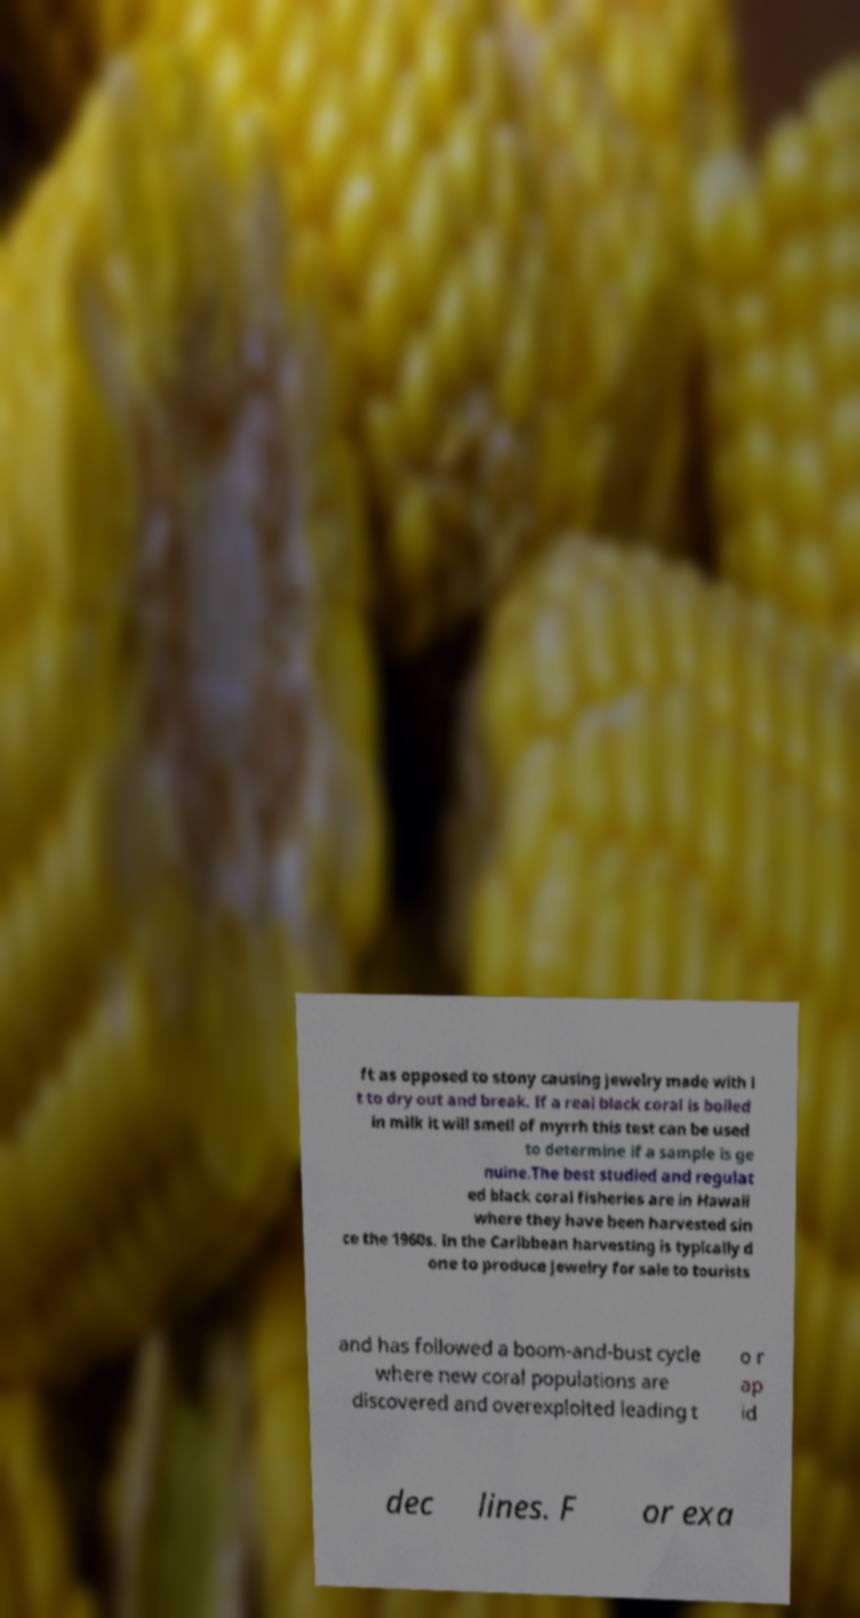I need the written content from this picture converted into text. Can you do that? ft as opposed to stony causing jewelry made with i t to dry out and break. If a real black coral is boiled in milk it will smell of myrrh this test can be used to determine if a sample is ge nuine.The best studied and regulat ed black coral fisheries are in Hawaii where they have been harvested sin ce the 1960s. In the Caribbean harvesting is typically d one to produce jewelry for sale to tourists and has followed a boom-and-bust cycle where new coral populations are discovered and overexploited leading t o r ap id dec lines. F or exa 